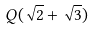<formula> <loc_0><loc_0><loc_500><loc_500>Q ( \sqrt { 2 } + \sqrt { 3 } )</formula> 